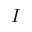Convert formula to latex. <formula><loc_0><loc_0><loc_500><loc_500>I</formula> 